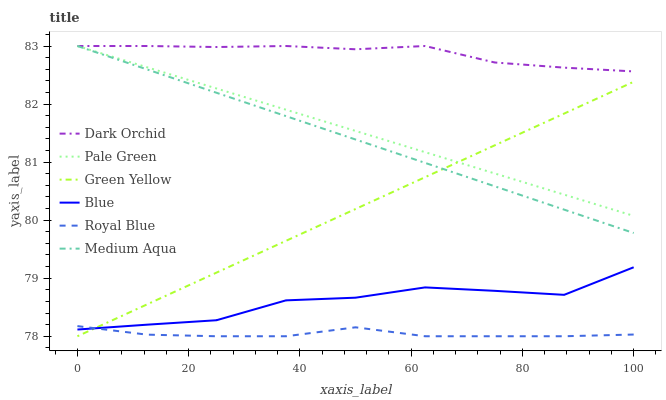Does Royal Blue have the minimum area under the curve?
Answer yes or no. Yes. Does Dark Orchid have the maximum area under the curve?
Answer yes or no. Yes. Does Dark Orchid have the minimum area under the curve?
Answer yes or no. No. Does Royal Blue have the maximum area under the curve?
Answer yes or no. No. Is Green Yellow the smoothest?
Answer yes or no. Yes. Is Blue the roughest?
Answer yes or no. Yes. Is Dark Orchid the smoothest?
Answer yes or no. No. Is Dark Orchid the roughest?
Answer yes or no. No. Does Dark Orchid have the lowest value?
Answer yes or no. No. Does Medium Aqua have the highest value?
Answer yes or no. Yes. Does Royal Blue have the highest value?
Answer yes or no. No. Is Blue less than Dark Orchid?
Answer yes or no. Yes. Is Dark Orchid greater than Blue?
Answer yes or no. Yes. Does Blue intersect Green Yellow?
Answer yes or no. Yes. Is Blue less than Green Yellow?
Answer yes or no. No. Is Blue greater than Green Yellow?
Answer yes or no. No. Does Blue intersect Dark Orchid?
Answer yes or no. No. 